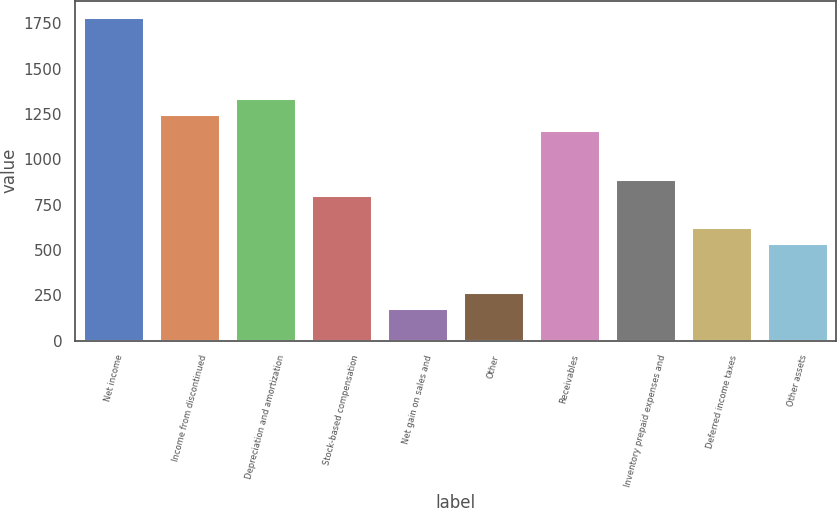<chart> <loc_0><loc_0><loc_500><loc_500><bar_chart><fcel>Net income<fcel>Income from discontinued<fcel>Depreciation and amortization<fcel>Stock-based compensation<fcel>Net gain on sales and<fcel>Other<fcel>Receivables<fcel>Inventory prepaid expenses and<fcel>Deferred income taxes<fcel>Other assets<nl><fcel>1786<fcel>1250.8<fcel>1340<fcel>804.8<fcel>180.4<fcel>269.6<fcel>1161.6<fcel>894<fcel>626.4<fcel>537.2<nl></chart> 